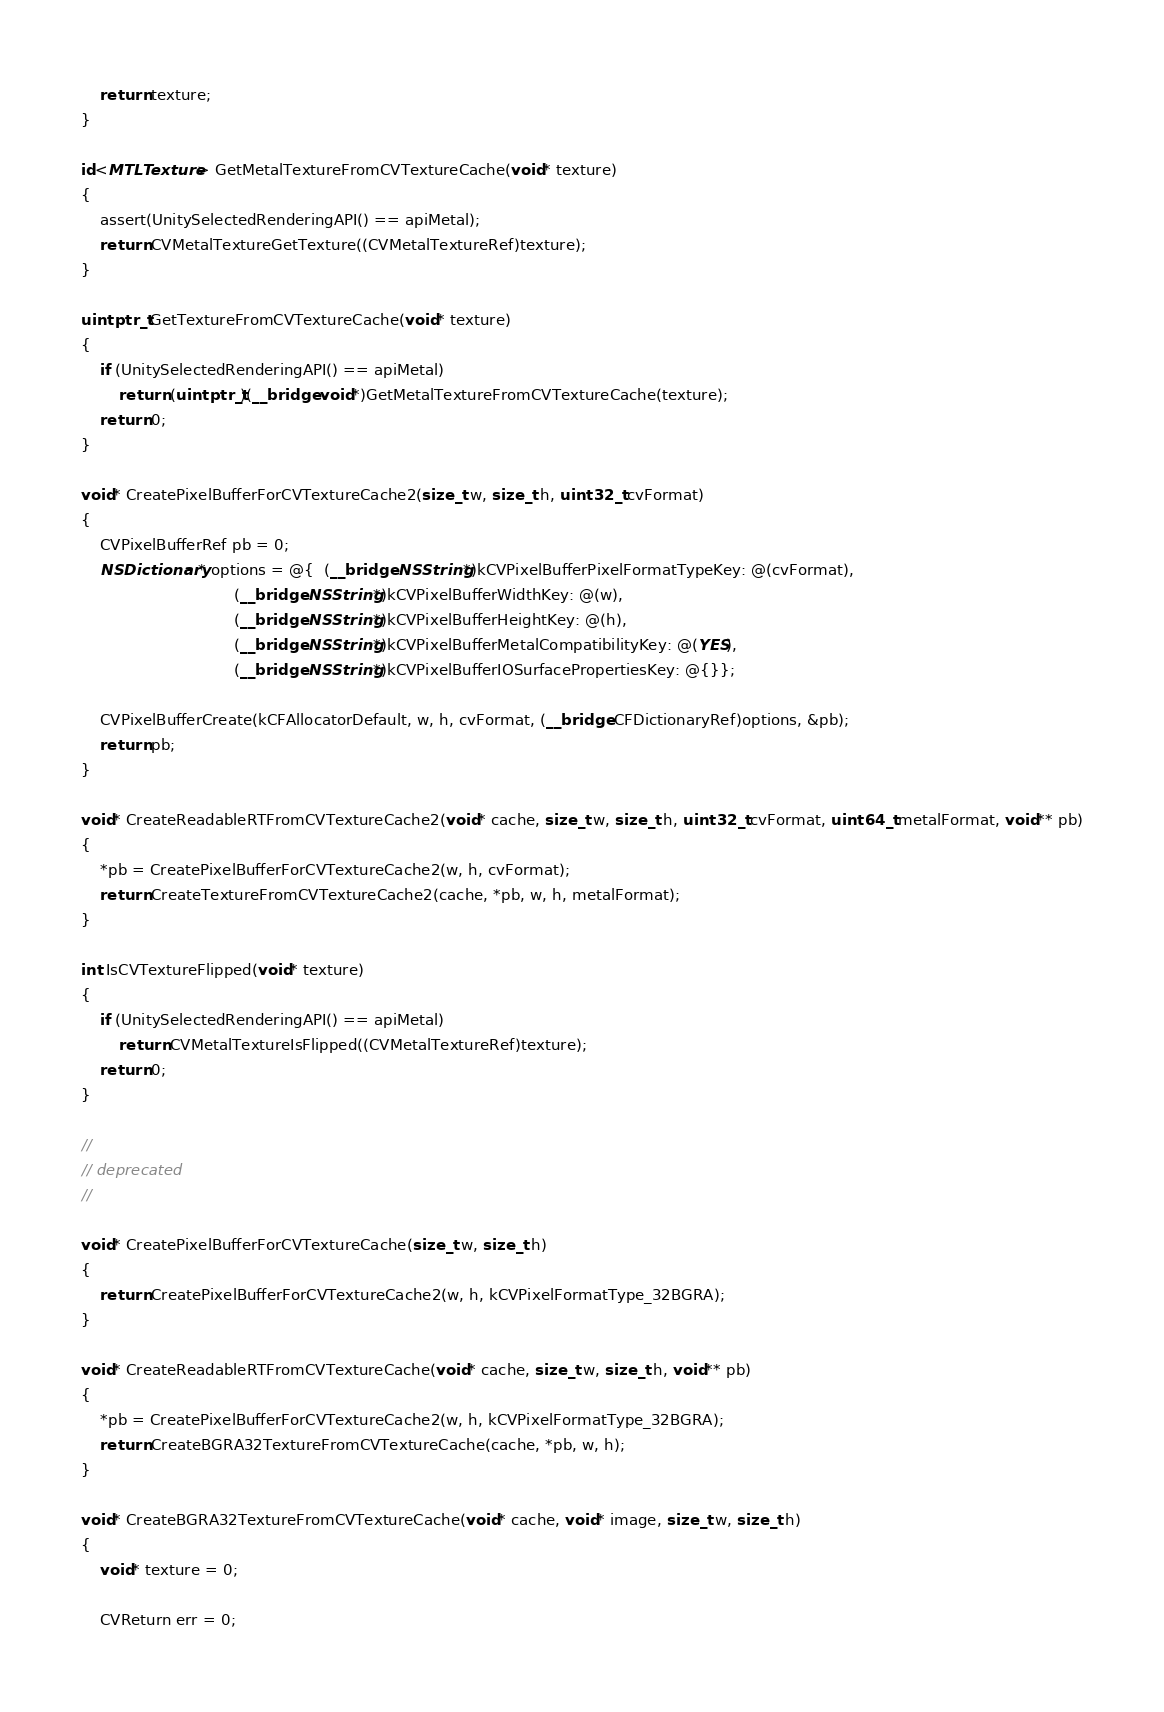Convert code to text. <code><loc_0><loc_0><loc_500><loc_500><_ObjectiveC_>    return texture;
}

id<MTLTexture> GetMetalTextureFromCVTextureCache(void* texture)
{
    assert(UnitySelectedRenderingAPI() == apiMetal);
    return CVMetalTextureGetTexture((CVMetalTextureRef)texture);
}

uintptr_t GetTextureFromCVTextureCache(void* texture)
{
    if (UnitySelectedRenderingAPI() == apiMetal)
        return (uintptr_t)(__bridge void*)GetMetalTextureFromCVTextureCache(texture);
    return 0;
}

void* CreatePixelBufferForCVTextureCache2(size_t w, size_t h, uint32_t cvFormat)
{
    CVPixelBufferRef pb = 0;
    NSDictionary* options = @{  (__bridge NSString*)kCVPixelBufferPixelFormatTypeKey: @(cvFormat),
                                (__bridge NSString*)kCVPixelBufferWidthKey: @(w),
                                (__bridge NSString*)kCVPixelBufferHeightKey: @(h),
                                (__bridge NSString*)kCVPixelBufferMetalCompatibilityKey: @(YES),
                                (__bridge NSString*)kCVPixelBufferIOSurfacePropertiesKey: @{}};

    CVPixelBufferCreate(kCFAllocatorDefault, w, h, cvFormat, (__bridge CFDictionaryRef)options, &pb);
    return pb;
}

void* CreateReadableRTFromCVTextureCache2(void* cache, size_t w, size_t h, uint32_t cvFormat, uint64_t metalFormat, void** pb)
{
    *pb = CreatePixelBufferForCVTextureCache2(w, h, cvFormat);
    return CreateTextureFromCVTextureCache2(cache, *pb, w, h, metalFormat);
}

int IsCVTextureFlipped(void* texture)
{
    if (UnitySelectedRenderingAPI() == apiMetal)
        return CVMetalTextureIsFlipped((CVMetalTextureRef)texture);
    return 0;
}

//
// deprecated
//

void* CreatePixelBufferForCVTextureCache(size_t w, size_t h)
{
    return CreatePixelBufferForCVTextureCache2(w, h, kCVPixelFormatType_32BGRA);
}

void* CreateReadableRTFromCVTextureCache(void* cache, size_t w, size_t h, void** pb)
{
    *pb = CreatePixelBufferForCVTextureCache2(w, h, kCVPixelFormatType_32BGRA);
    return CreateBGRA32TextureFromCVTextureCache(cache, *pb, w, h);
}

void* CreateBGRA32TextureFromCVTextureCache(void* cache, void* image, size_t w, size_t h)
{
    void* texture = 0;

    CVReturn err = 0;</code> 